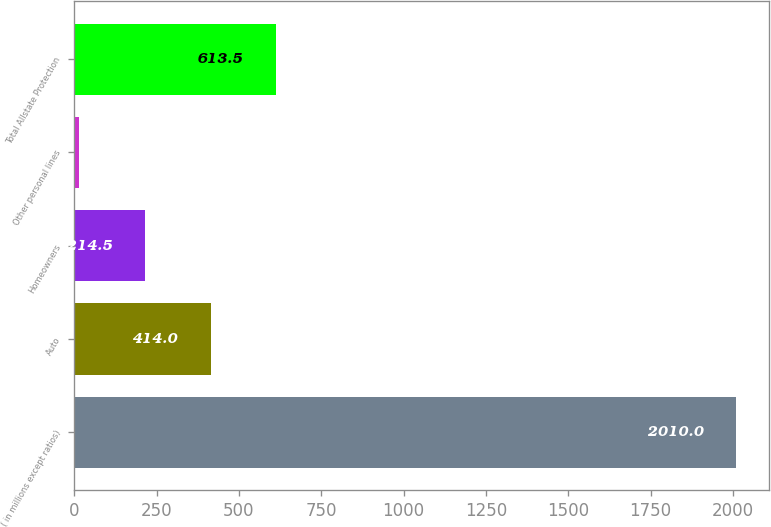Convert chart to OTSL. <chart><loc_0><loc_0><loc_500><loc_500><bar_chart><fcel>( in millions except ratios)<fcel>Auto<fcel>Homeowners<fcel>Other personal lines<fcel>Total Allstate Protection<nl><fcel>2010<fcel>414<fcel>214.5<fcel>15<fcel>613.5<nl></chart> 